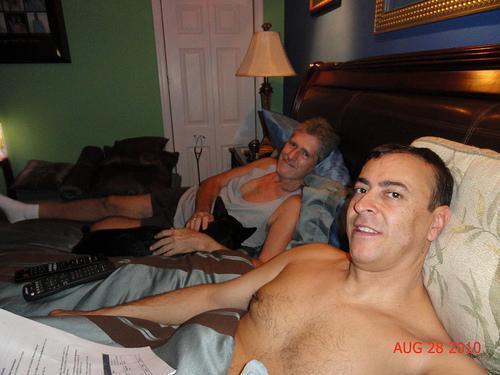How many remote controls are in the picture?
Give a very brief answer. 2. How many people are wearing a shirt?
Give a very brief answer. 1. How many men are wearing shirts?
Give a very brief answer. 1. 